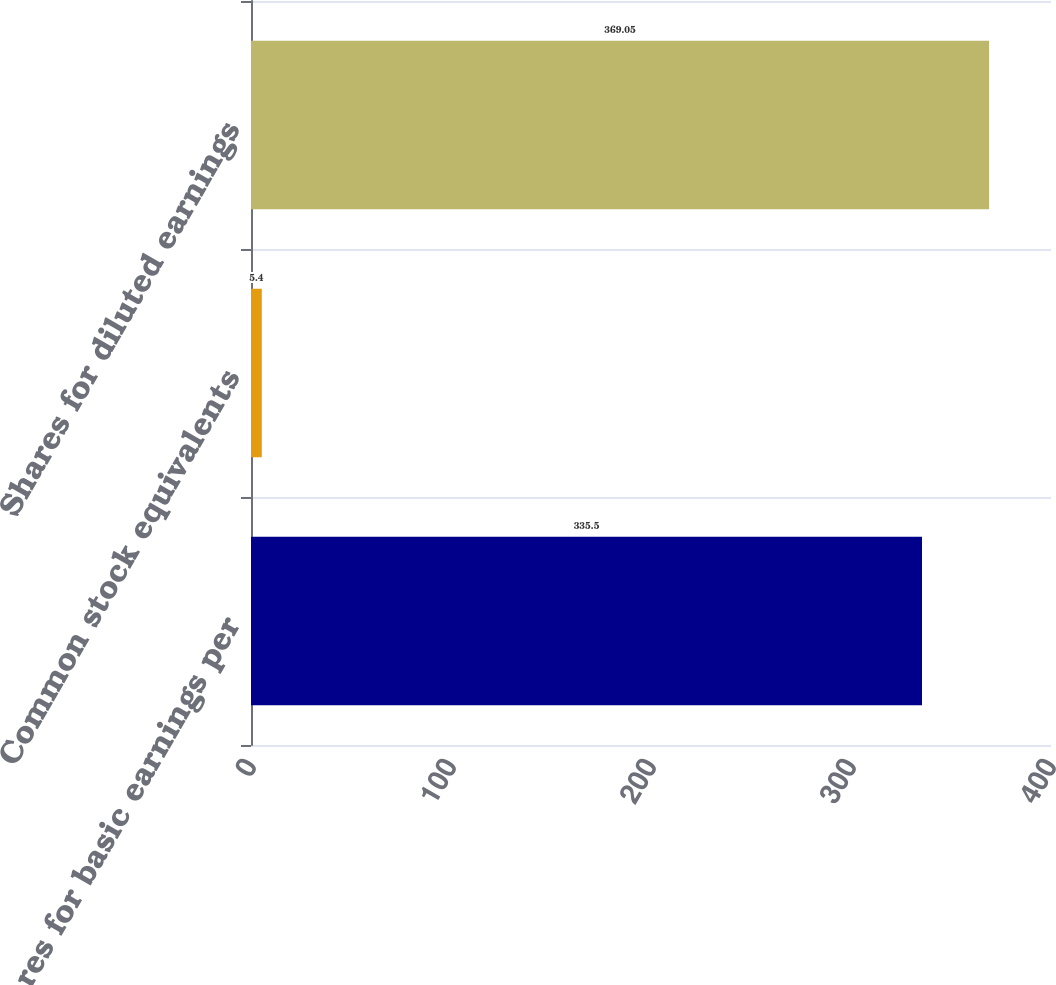Convert chart to OTSL. <chart><loc_0><loc_0><loc_500><loc_500><bar_chart><fcel>Shares for basic earnings per<fcel>Common stock equivalents<fcel>Shares for diluted earnings<nl><fcel>335.5<fcel>5.4<fcel>369.05<nl></chart> 